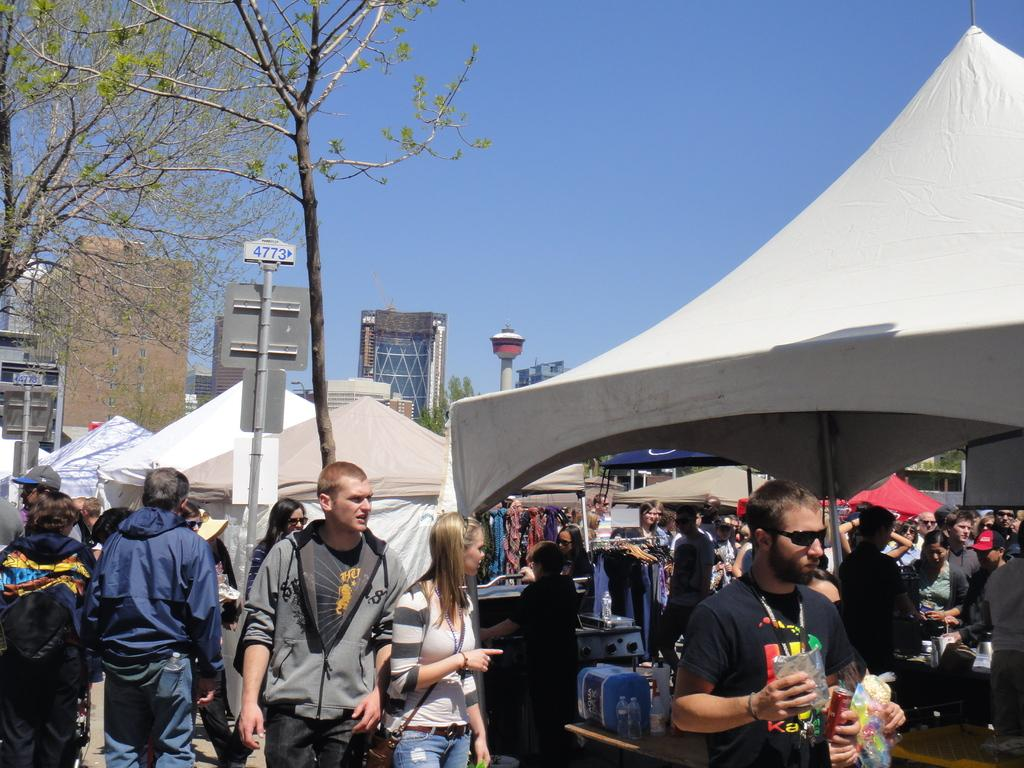What are the people in the image doing? There are people standing in the image, and some of them are buying something under a shed. What can be seen in the background of the image? There are buildings, trees, and the sky visible in the background of the image. What tax is being discussed by the people in the image? There is no indication in the image that the people are discussing any taxes. 